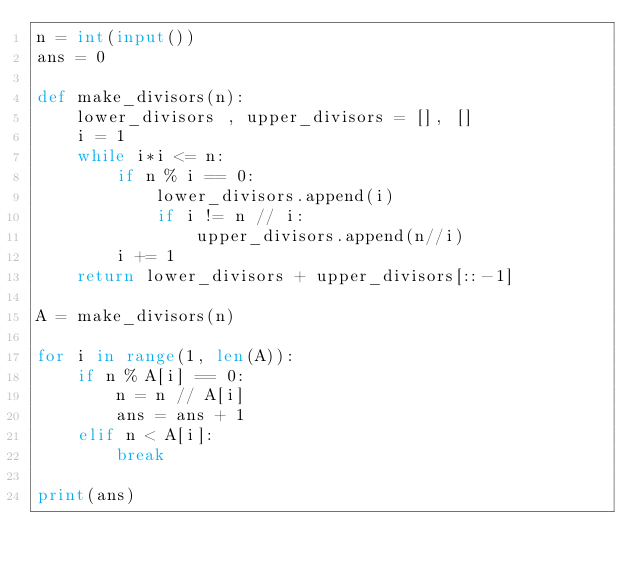Convert code to text. <code><loc_0><loc_0><loc_500><loc_500><_Python_>n = int(input())
ans = 0

def make_divisors(n):
    lower_divisors , upper_divisors = [], []
    i = 1
    while i*i <= n:
        if n % i == 0:
            lower_divisors.append(i)
            if i != n // i:
                upper_divisors.append(n//i)
        i += 1
    return lower_divisors + upper_divisors[::-1]

A = make_divisors(n)

for i in range(1, len(A)):
    if n % A[i] == 0:
        n = n // A[i]
        ans = ans + 1
    elif n < A[i]:
        break

print(ans)</code> 